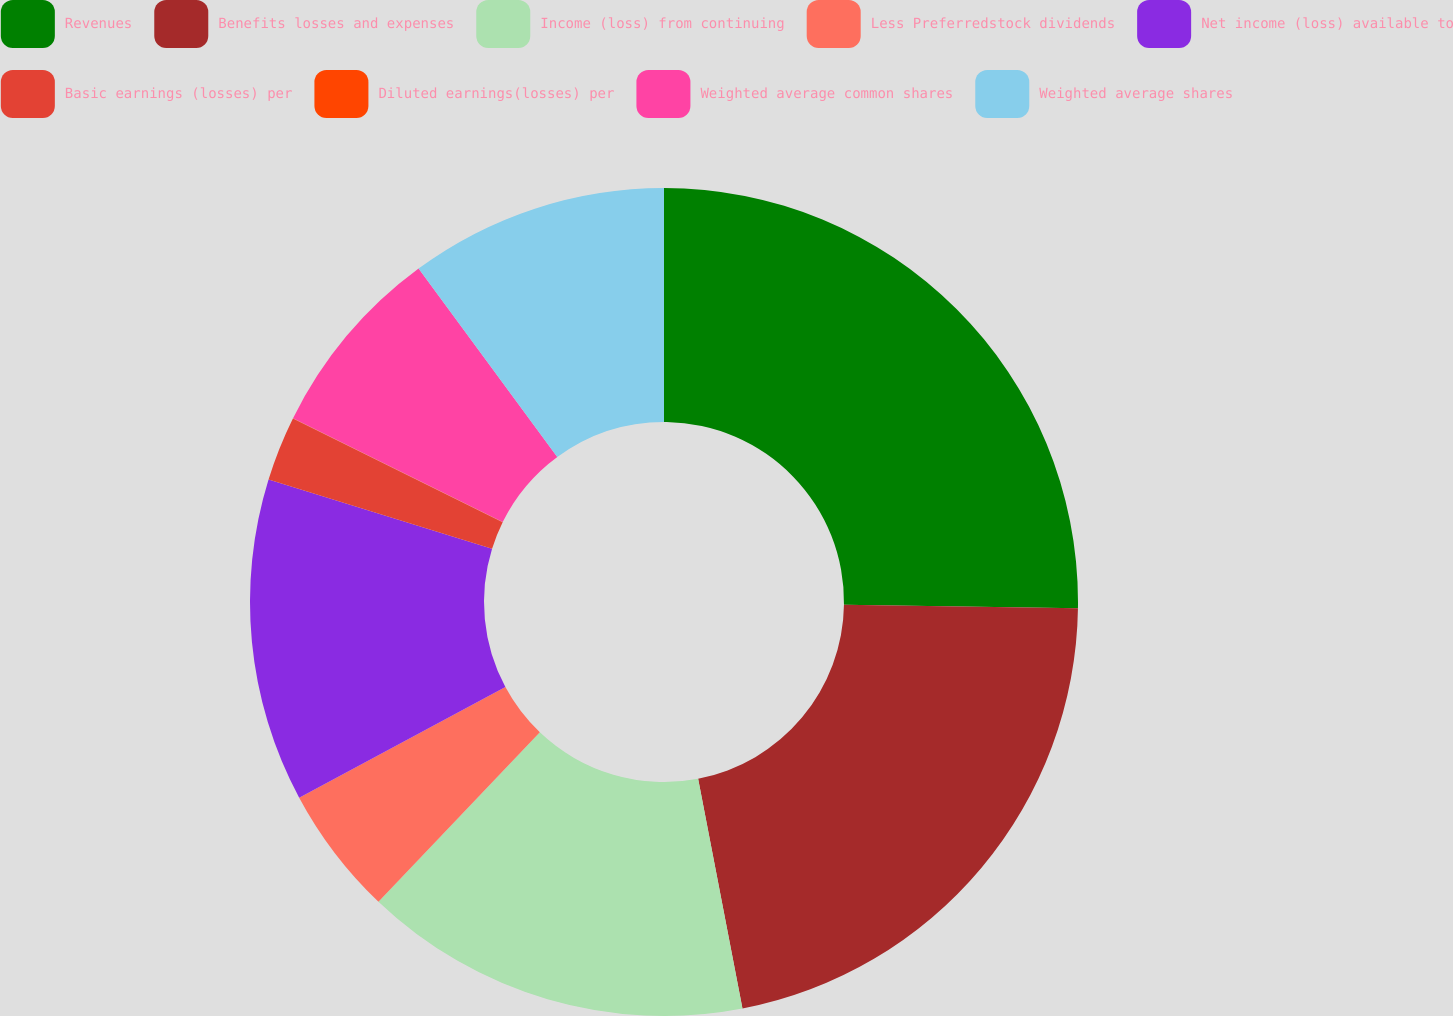Convert chart. <chart><loc_0><loc_0><loc_500><loc_500><pie_chart><fcel>Revenues<fcel>Benefits losses and expenses<fcel>Income (loss) from continuing<fcel>Less Preferredstock dividends<fcel>Net income (loss) available to<fcel>Basic earnings (losses) per<fcel>Diluted earnings(losses) per<fcel>Weighted average common shares<fcel>Weighted average shares<nl><fcel>25.24%<fcel>21.73%<fcel>15.15%<fcel>5.05%<fcel>12.62%<fcel>2.53%<fcel>0.01%<fcel>7.58%<fcel>10.1%<nl></chart> 